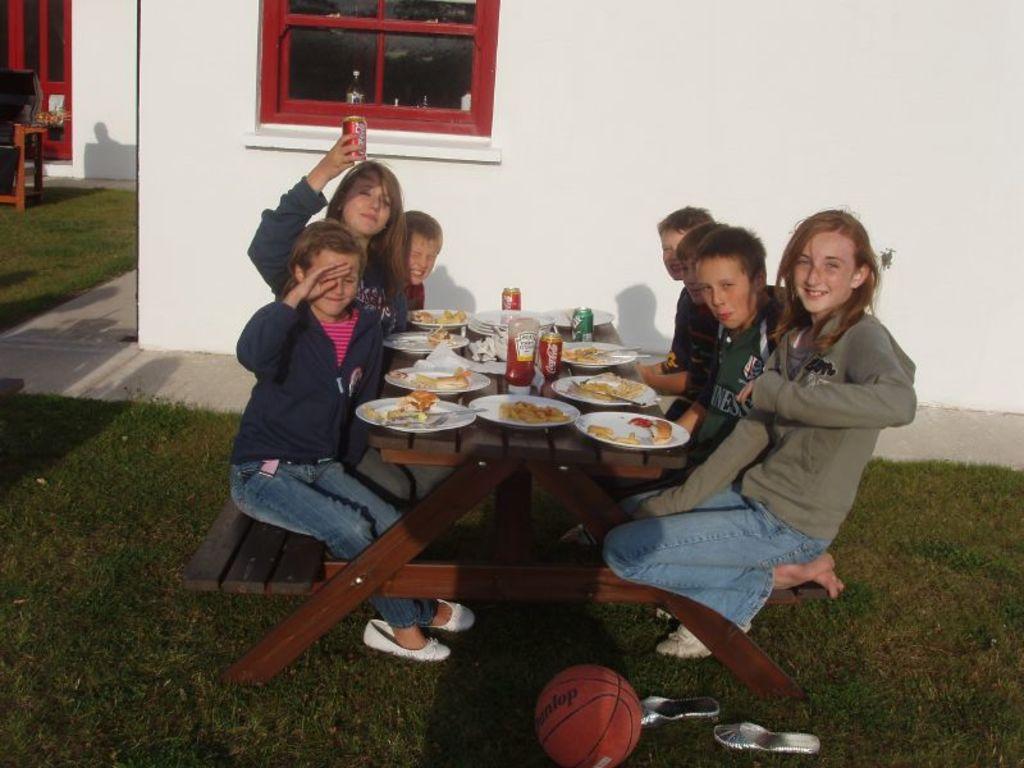Describe this image in one or two sentences. There are six kids sitting on the bench. In front of them there is a table. On the table there are 8 planets, one ketchup bottle, coke tin, tissue papers and a water bottle on it. Beside them there is a volleyball. And to the bottom there is a grass. In the background there is a window which is in red color. And to the top left corner there is a sofa and a door. 